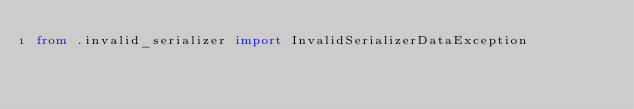Convert code to text. <code><loc_0><loc_0><loc_500><loc_500><_Python_>from .invalid_serializer import InvalidSerializerDataException
</code> 